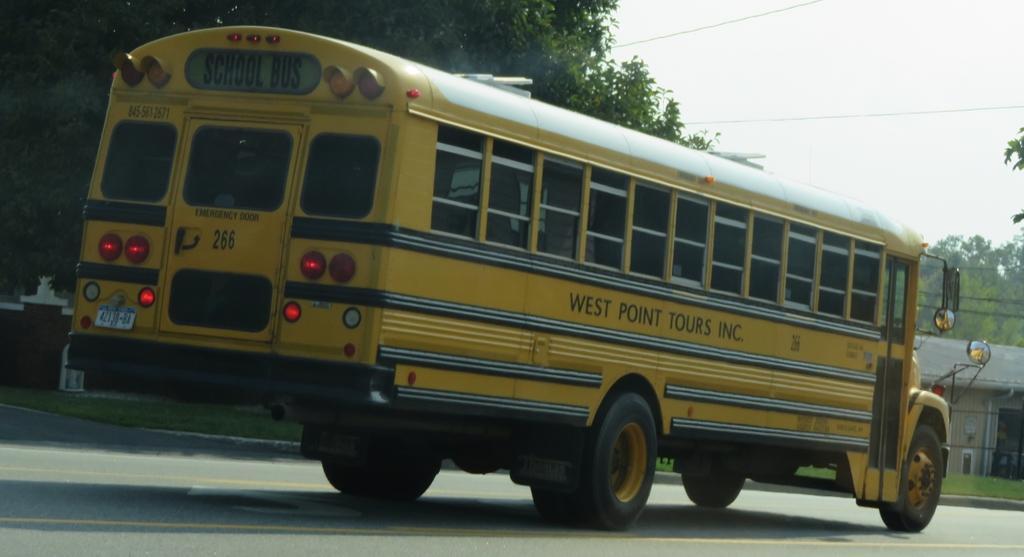Can you describe this image briefly? In this image I can see yellow color bus is moving on the road, on the left side there are trees. On the left side it looks like a house, at the top it is the sky. 